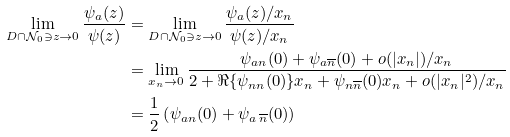Convert formula to latex. <formula><loc_0><loc_0><loc_500><loc_500>\lim _ { D \cap \mathcal { N } _ { 0 } \ni z \rightarrow 0 } \frac { \psi _ { a } ( z ) } { \psi ( z ) } & = \lim _ { D \cap \mathcal { N } _ { 0 } \ni z \rightarrow 0 } \frac { \psi _ { a } ( z ) / x _ { n } } { \psi ( z ) / x _ { n } } \\ & = \lim _ { x _ { n } \rightarrow 0 } \frac { \psi _ { a n } ( 0 ) + \psi _ { a \overline { n } } ( 0 ) + o ( | x _ { n } | ) / x _ { n } } { 2 + \Re \{ \psi _ { n n } ( 0 ) \} x _ { n } + \psi _ { n \overline { n } } ( 0 ) x _ { n } + o ( | x _ { n } | ^ { 2 } ) / x _ { n } } \\ & = \frac { 1 } { 2 } \left ( \psi _ { a n } ( 0 ) + \psi _ { a \, \overline { n } } ( 0 ) \right )</formula> 